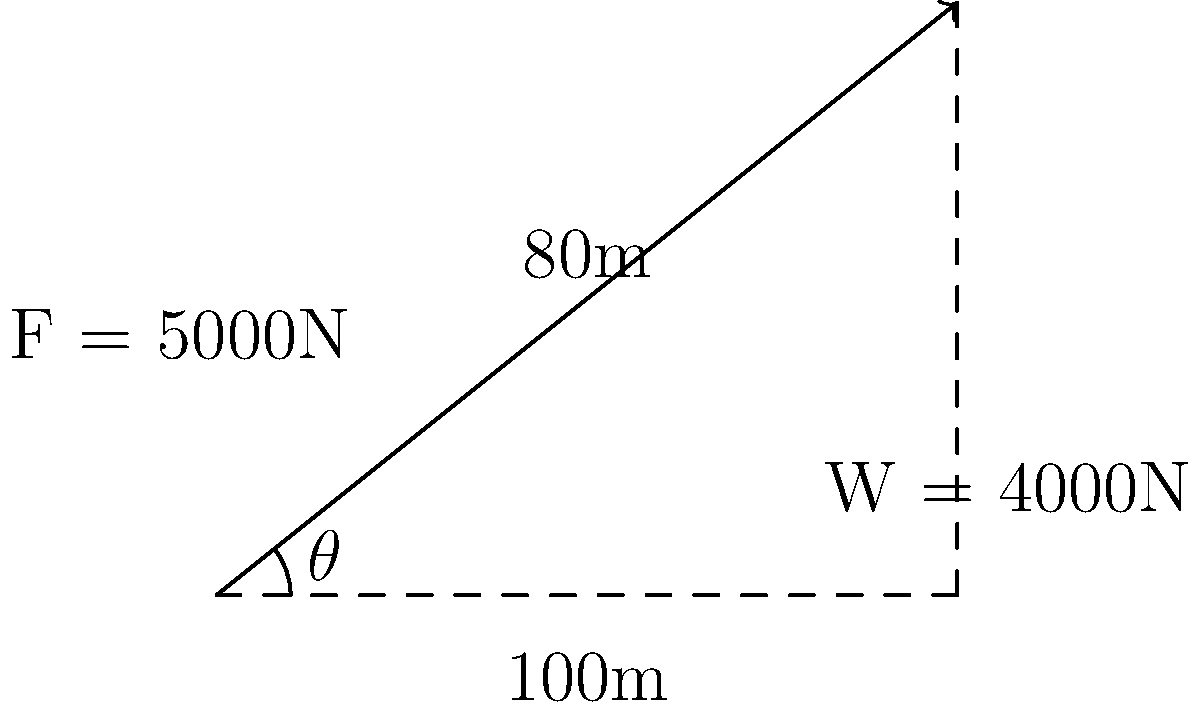A cable car system in the mountainous region of Jahorina, Bosnia and Herzegovina, travels along a cable that rises 80 meters over a horizontal distance of 100 meters. The car and its passengers have a total weight of 4000N, and the tension in the cable is 5000N. Calculate the mechanical efficiency of this cable car system. To calculate the mechanical efficiency of the cable car system, we need to follow these steps:

1. Calculate the angle of inclination:
   $\theta = \tan^{-1}(\frac{80}{100}) = 38.7°$

2. Calculate the work output (useful work):
   Work output = Weight × Vertical distance
   $W_{out} = 4000\text{N} \times 80\text{m} = 320,000\text{J}$

3. Calculate the work input:
   Work input = Force × Distance along the cable
   Distance along the cable = $\sqrt{100^2 + 80^2} = 128.06\text{m}$
   $W_{in} = 5000\text{N} \times 128.06\text{m} = 640,300\text{J}$

4. Calculate the mechanical efficiency:
   Efficiency = $\frac{\text{Work output}}{\text{Work input}} \times 100\%$
   $\text{Efficiency} = \frac{320,000\text{J}}{640,300\text{J}} \times 100\% = 49.98\%$

Therefore, the mechanical efficiency of the cable car system is approximately 50%.
Answer: 50% 